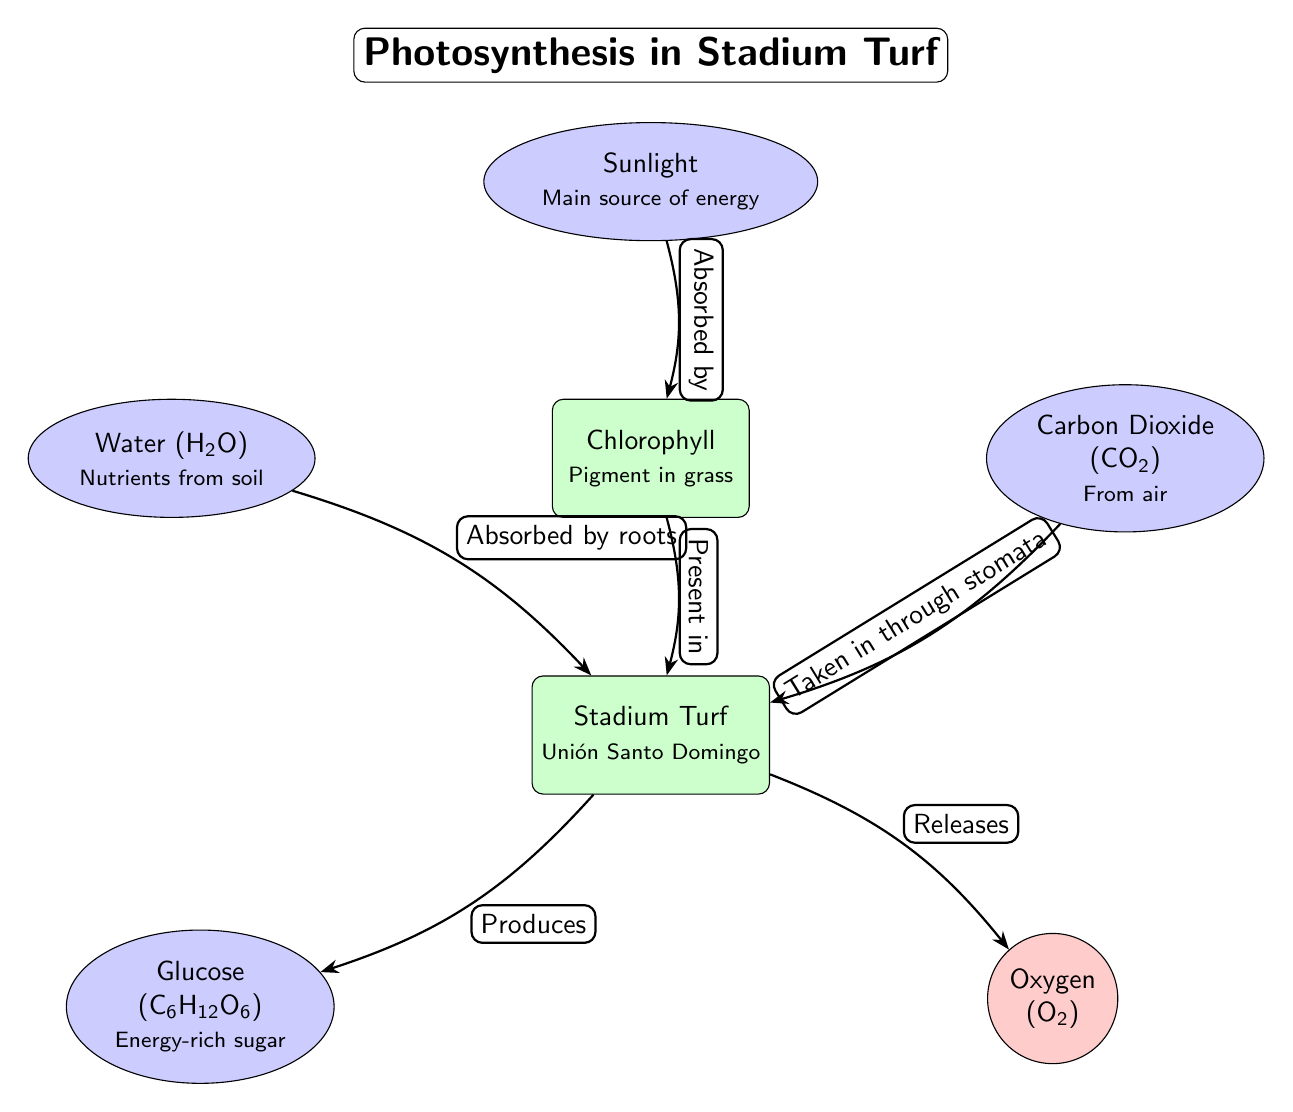What is the main source of energy for photosynthesis in turf? The diagram indicates that the main source of energy is sunlight, which is shown as the top node. The connection between sunlight and chlorophyll further emphasizes its role in powering the photosynthesis process.
Answer: Sunlight What pigment in grass is responsible for photosynthesis? The diagram identifies chlorophyll as the pigment in grass that facilitates photosynthesis. It is directly below the sunlight node, indicating its importance in the process.
Answer: Chlorophyll How many products are generated from the turf? By examining the outputs of the turf node in the diagram, we find two products: glucose and oxygen. Therefore, the total number of products is two.
Answer: Two What is absorbed by the roots of the turf? The diagram indicates that water, which is a nutrient from the soil, is absorbed by the roots of the turf. This relation is depicted with a direct edge from the water node to the turf node.
Answer: Water What does the turf produce as a result of photosynthesis? According to the diagram, turf produces glucose as an energy-rich sugar, which is indicated by the arrow pointing from the turf node to the glucose node.
Answer: Glucose What gas is released by the turf during photosynthesis? The diagram shows that oxygen is released by the turf as a byproduct of the photosynthesis process. This is highlighted with a direct edge from the turf node to the oxygen node.
Answer: Oxygen Which element is taken in through stomata? The diagram specifies that carbon dioxide, represented by the CO2 node, is taken in through stomata of the grass. This relationship is indicated by the arrow directing from the CO2 node to the turf node.
Answer: Carbon Dioxide What pigment is found in grass according to the diagram? The chlorophyll node clearly states that chlorophyll is the pigment present in grass, highlighting its vital role in the process.
Answer: Chlorophyll What type of diagram is used to represent photosynthesis in this context? This is a natural science diagram, specifically structured to visualize the process of photosynthesis in stadium turf, accommodating various elements and their interactions.
Answer: Natural Science Diagram 